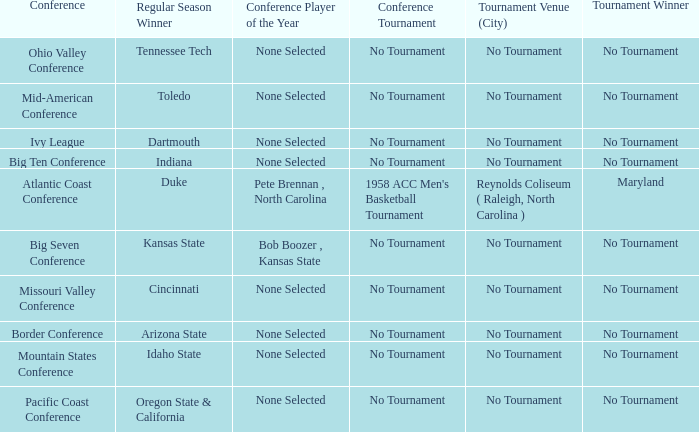Who won the regular season when Maryland won the tournament? Duke. Help me parse the entirety of this table. {'header': ['Conference', 'Regular Season Winner', 'Conference Player of the Year', 'Conference Tournament', 'Tournament Venue (City)', 'Tournament Winner'], 'rows': [['Ohio Valley Conference', 'Tennessee Tech', 'None Selected', 'No Tournament', 'No Tournament', 'No Tournament'], ['Mid-American Conference', 'Toledo', 'None Selected', 'No Tournament', 'No Tournament', 'No Tournament'], ['Ivy League', 'Dartmouth', 'None Selected', 'No Tournament', 'No Tournament', 'No Tournament'], ['Big Ten Conference', 'Indiana', 'None Selected', 'No Tournament', 'No Tournament', 'No Tournament'], ['Atlantic Coast Conference', 'Duke', 'Pete Brennan , North Carolina', "1958 ACC Men's Basketball Tournament", 'Reynolds Coliseum ( Raleigh, North Carolina )', 'Maryland'], ['Big Seven Conference', 'Kansas State', 'Bob Boozer , Kansas State', 'No Tournament', 'No Tournament', 'No Tournament'], ['Missouri Valley Conference', 'Cincinnati', 'None Selected', 'No Tournament', 'No Tournament', 'No Tournament'], ['Border Conference', 'Arizona State', 'None Selected', 'No Tournament', 'No Tournament', 'No Tournament'], ['Mountain States Conference', 'Idaho State', 'None Selected', 'No Tournament', 'No Tournament', 'No Tournament'], ['Pacific Coast Conference', 'Oregon State & California', 'None Selected', 'No Tournament', 'No Tournament', 'No Tournament']]} 